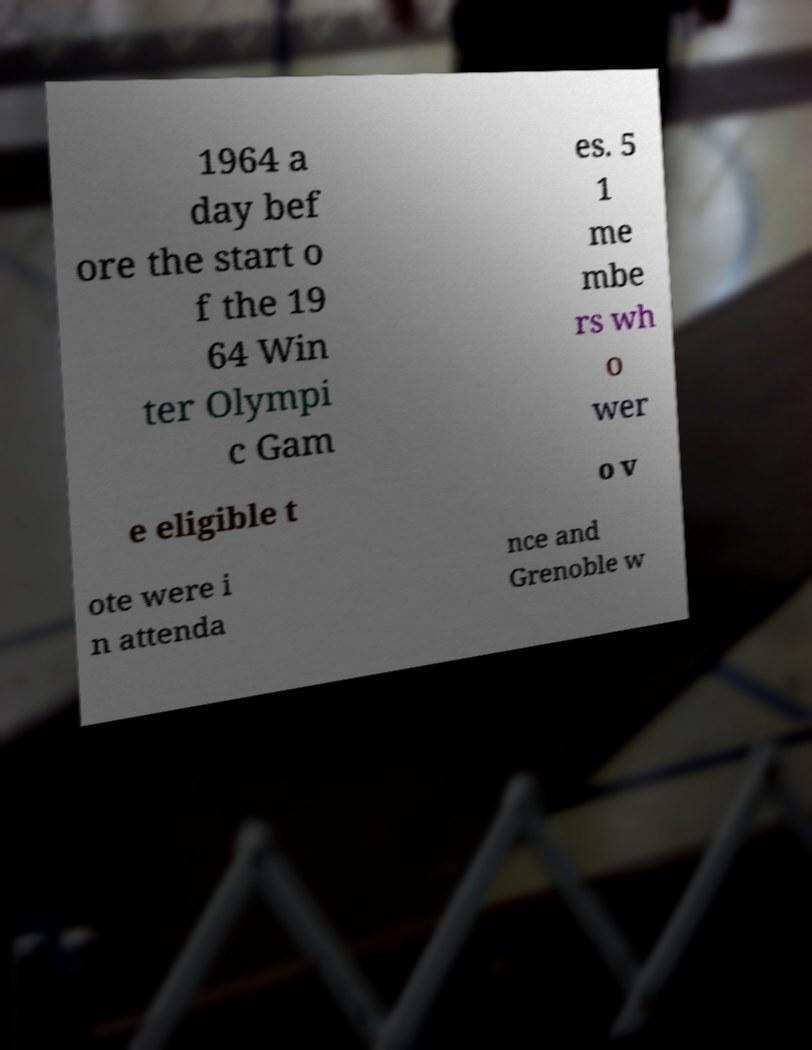Could you extract and type out the text from this image? 1964 a day bef ore the start o f the 19 64 Win ter Olympi c Gam es. 5 1 me mbe rs wh o wer e eligible t o v ote were i n attenda nce and Grenoble w 